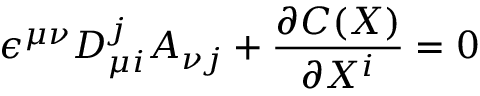Convert formula to latex. <formula><loc_0><loc_0><loc_500><loc_500>\epsilon ^ { \mu \nu } D _ { \mu i } ^ { j } A _ { \nu j } + \frac { \partial C ( X ) } { \partial X ^ { i } } = 0</formula> 